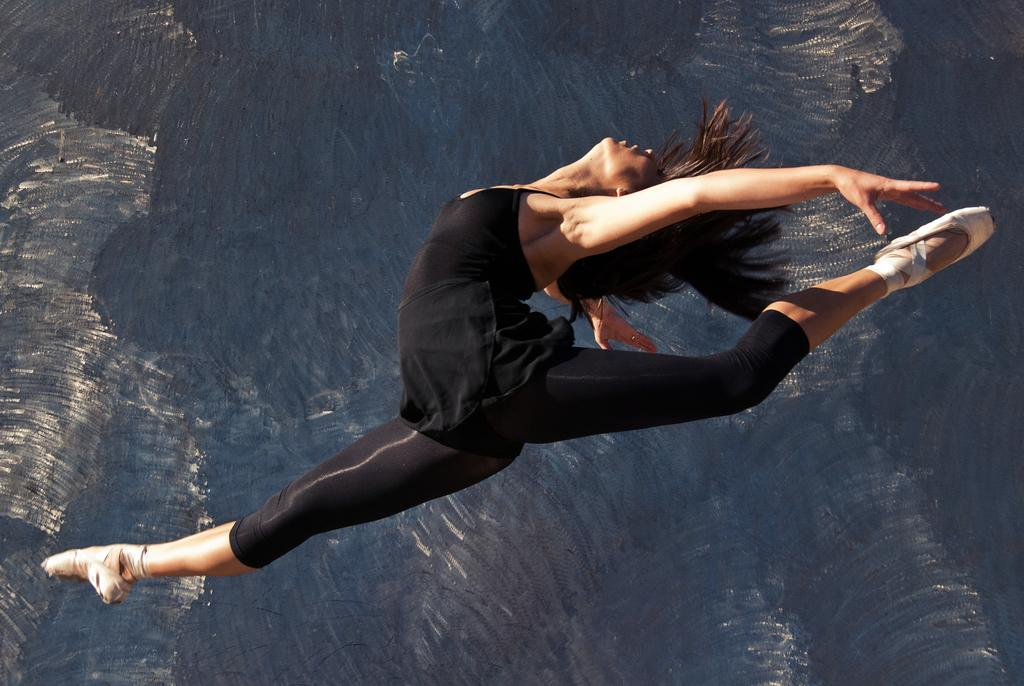What is the main subject of the image? The main subject of the image is a woman. What is the woman doing in the image? The woman is performing a stunt in the image. What is the tax rate for the horn industry in the afternoon in the image? There is no reference to tax rates, horns, or the time of day in the image, so it's not possible to answer that question. 